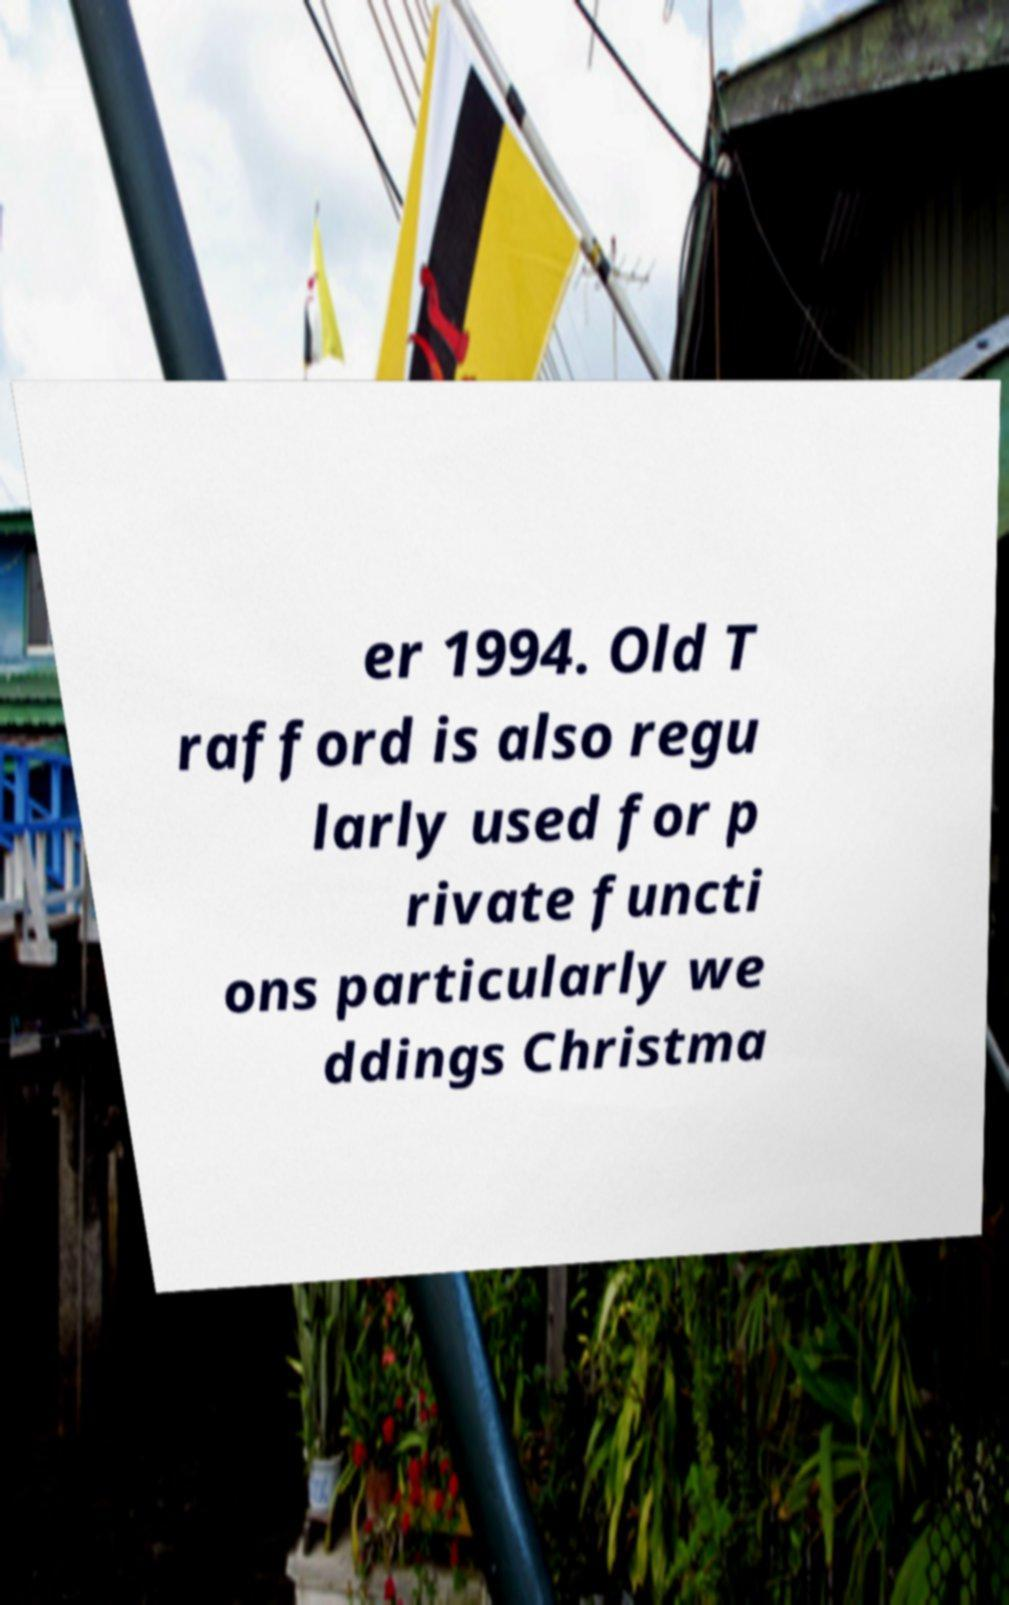Could you extract and type out the text from this image? er 1994. Old T rafford is also regu larly used for p rivate functi ons particularly we ddings Christma 